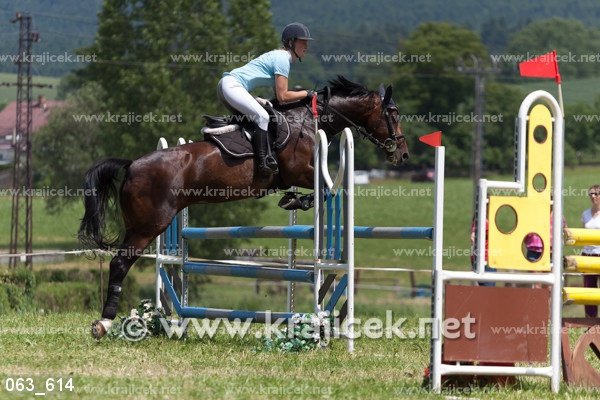Describe the objects in this image and their specific colors. I can see horse in gray, black, and maroon tones, people in gray, white, black, and lightblue tones, people in gray, white, and darkgray tones, and people in gray, black, darkblue, and brown tones in this image. 